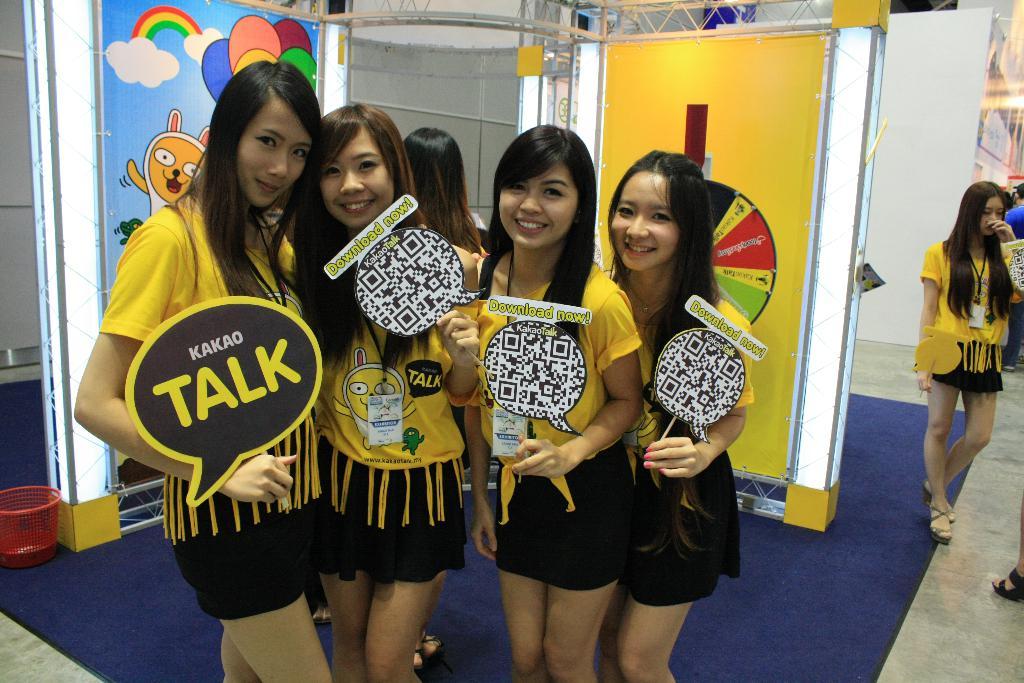What do the signs say?
Make the answer very short. Talk. 